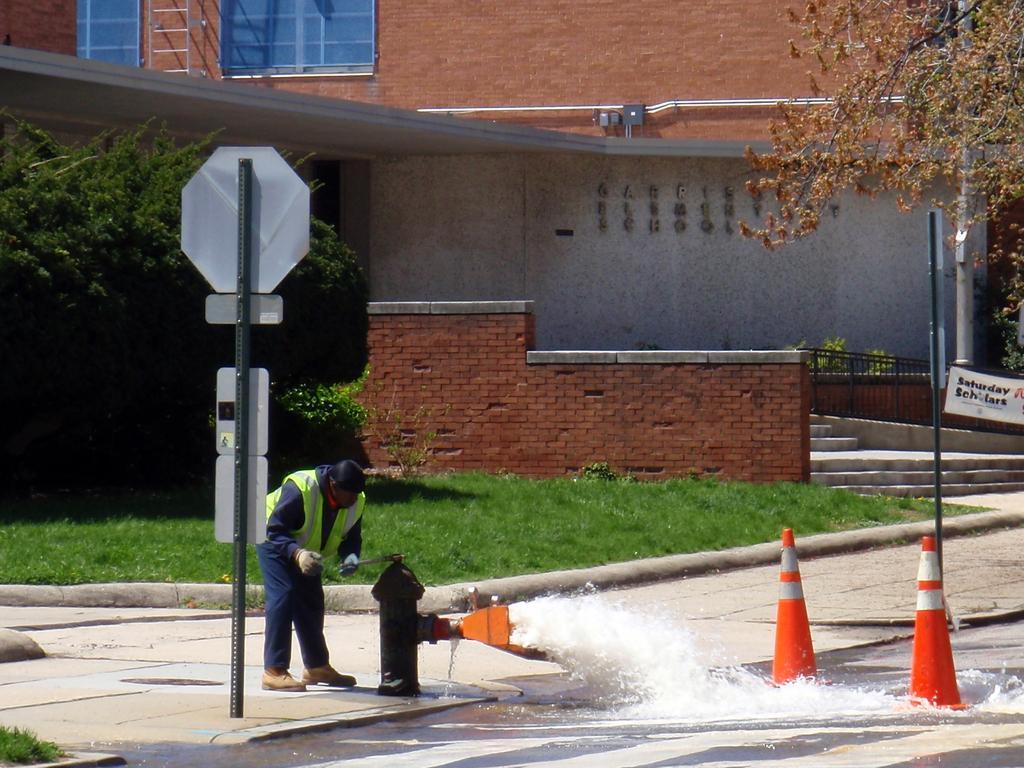Can you describe this image briefly? In this image there are cone bar barricades, water flowing from the fire hydrant, boards attached to the poles, a person standing, house, grass, plants. 